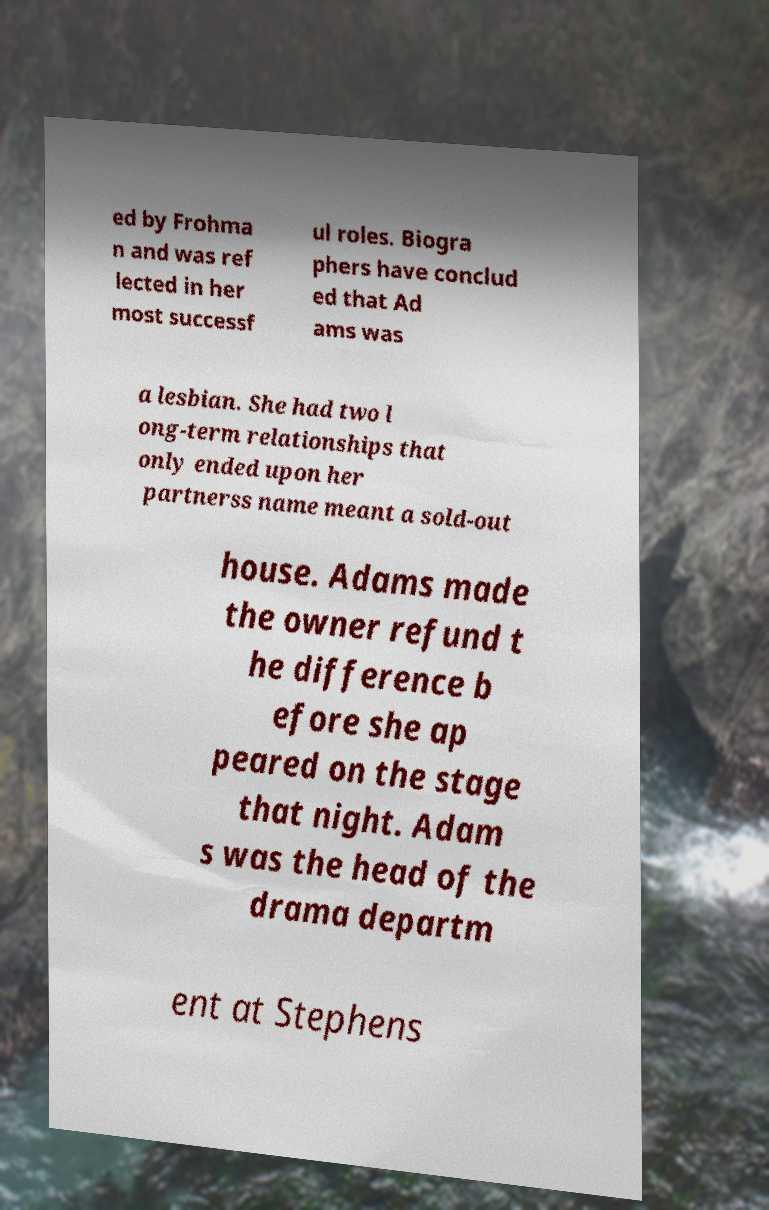Could you extract and type out the text from this image? ed by Frohma n and was ref lected in her most successf ul roles. Biogra phers have conclud ed that Ad ams was a lesbian. She had two l ong-term relationships that only ended upon her partnerss name meant a sold-out house. Adams made the owner refund t he difference b efore she ap peared on the stage that night. Adam s was the head of the drama departm ent at Stephens 